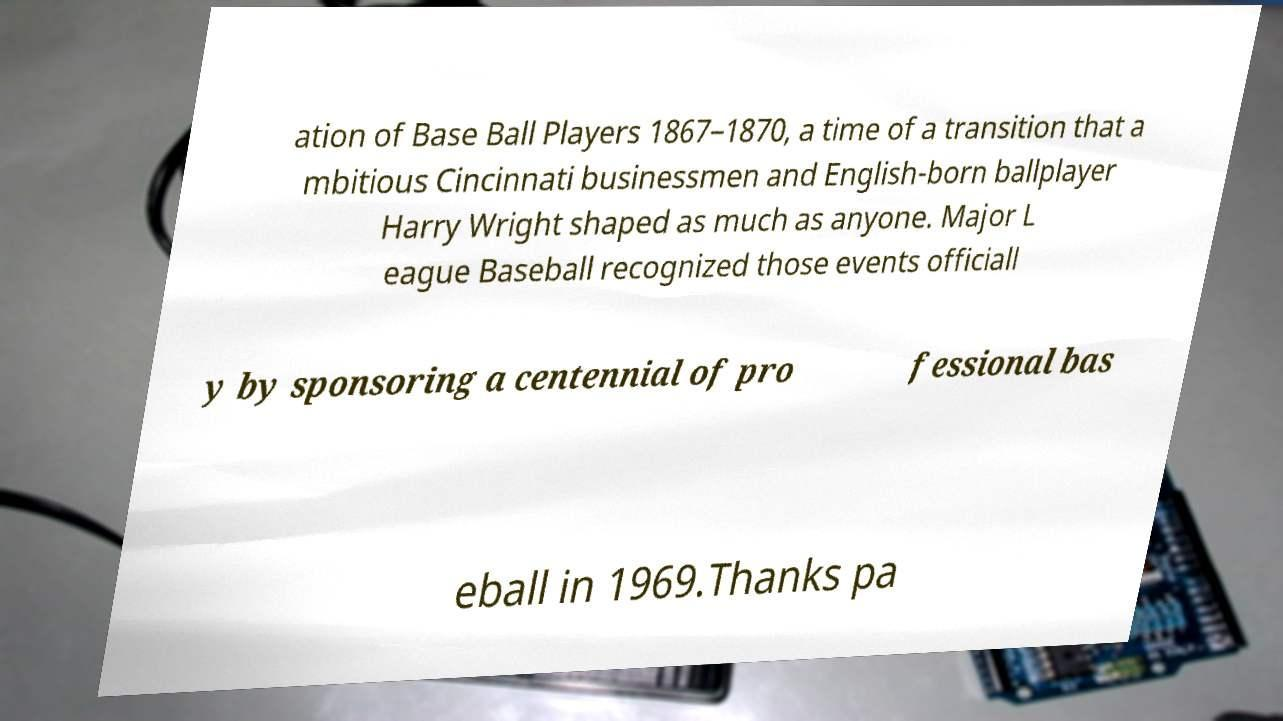Please read and relay the text visible in this image. What does it say? ation of Base Ball Players 1867–1870, a time of a transition that a mbitious Cincinnati businessmen and English-born ballplayer Harry Wright shaped as much as anyone. Major L eague Baseball recognized those events officiall y by sponsoring a centennial of pro fessional bas eball in 1969.Thanks pa 